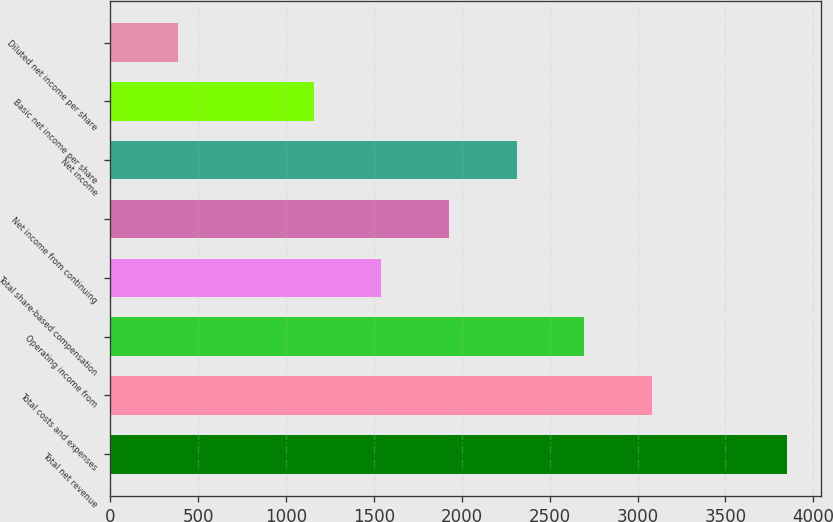Convert chart. <chart><loc_0><loc_0><loc_500><loc_500><bar_chart><fcel>Total net revenue<fcel>Total costs and expenses<fcel>Operating income from<fcel>Total share-based compensation<fcel>Net income from continuing<fcel>Net income<fcel>Basic net income per share<fcel>Diluted net income per share<nl><fcel>3851<fcel>3081.2<fcel>2696.3<fcel>1541.6<fcel>1926.5<fcel>2311.4<fcel>1156.7<fcel>386.9<nl></chart> 